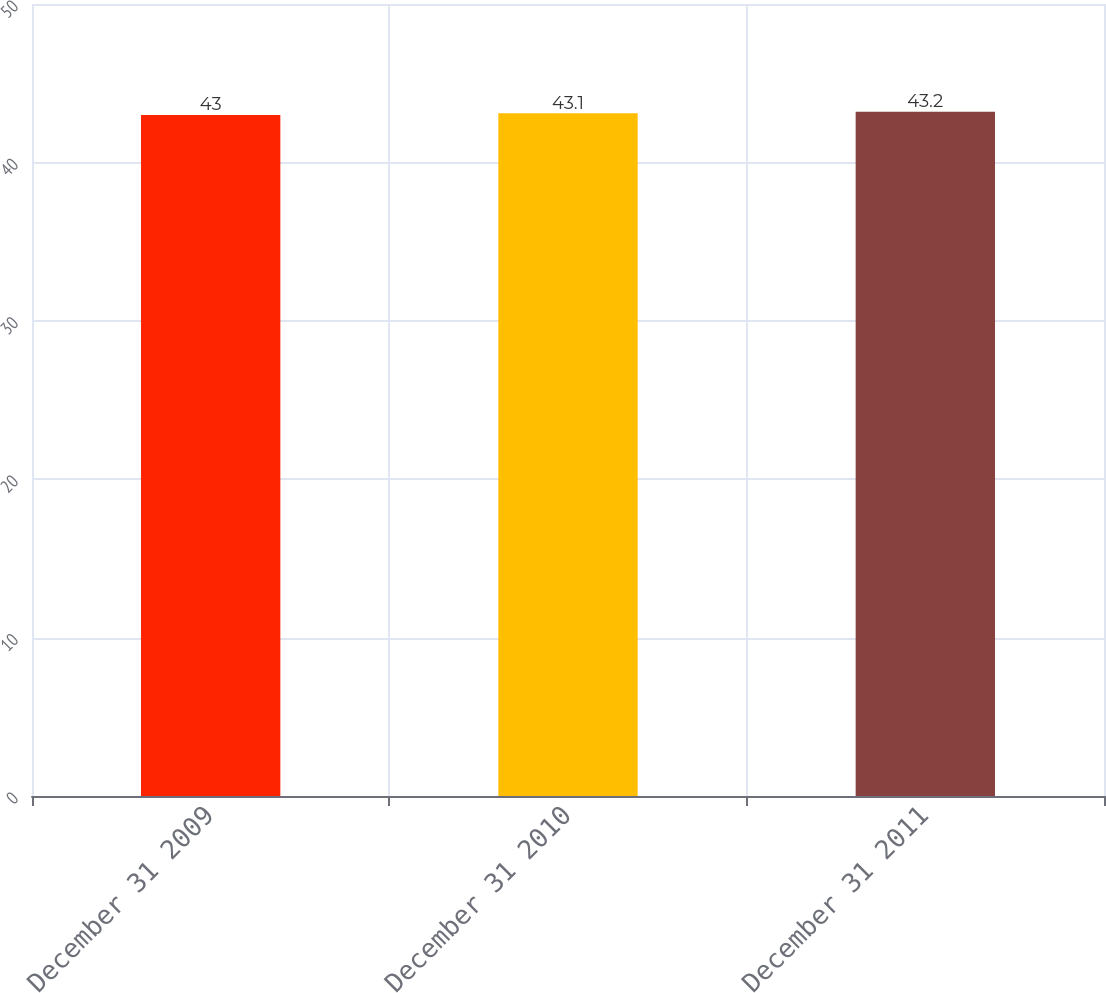Convert chart. <chart><loc_0><loc_0><loc_500><loc_500><bar_chart><fcel>December 31 2009<fcel>December 31 2010<fcel>December 31 2011<nl><fcel>43<fcel>43.1<fcel>43.2<nl></chart> 